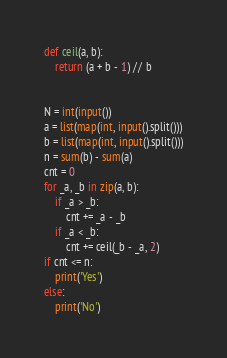Convert code to text. <code><loc_0><loc_0><loc_500><loc_500><_Python_>def ceil(a, b):
    return (a + b - 1) // b


N = int(input())
a = list(map(int, input().split()))
b = list(map(int, input().split()))
n = sum(b) - sum(a)
cnt = 0
for _a, _b in zip(a, b):
    if _a > _b:
        cnt += _a - _b
    if _a < _b:
        cnt += ceil(_b - _a, 2)
if cnt <= n:
    print('Yes')
else:
    print('No')
</code> 